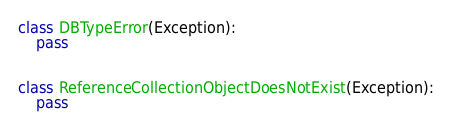Convert code to text. <code><loc_0><loc_0><loc_500><loc_500><_Python_>class DBTypeError(Exception):
    pass


class ReferenceCollectionObjectDoesNotExist(Exception):
    pass
</code> 